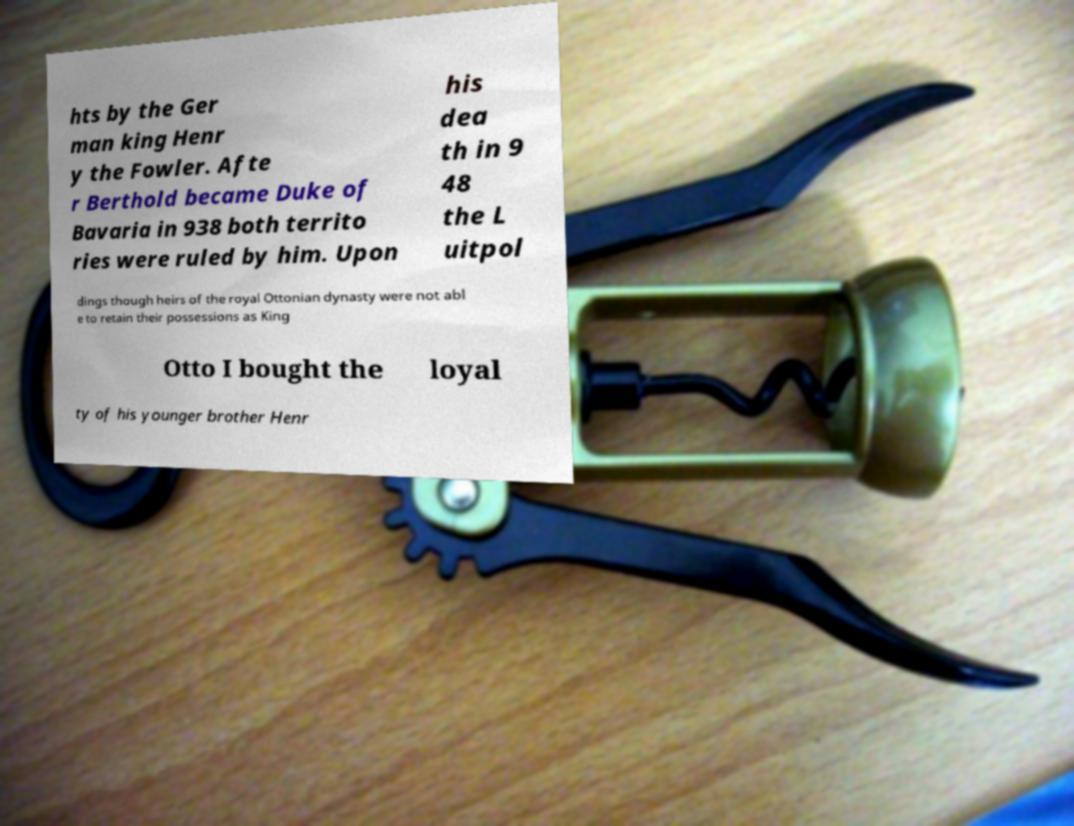I need the written content from this picture converted into text. Can you do that? hts by the Ger man king Henr y the Fowler. Afte r Berthold became Duke of Bavaria in 938 both territo ries were ruled by him. Upon his dea th in 9 48 the L uitpol dings though heirs of the royal Ottonian dynasty were not abl e to retain their possessions as King Otto I bought the loyal ty of his younger brother Henr 